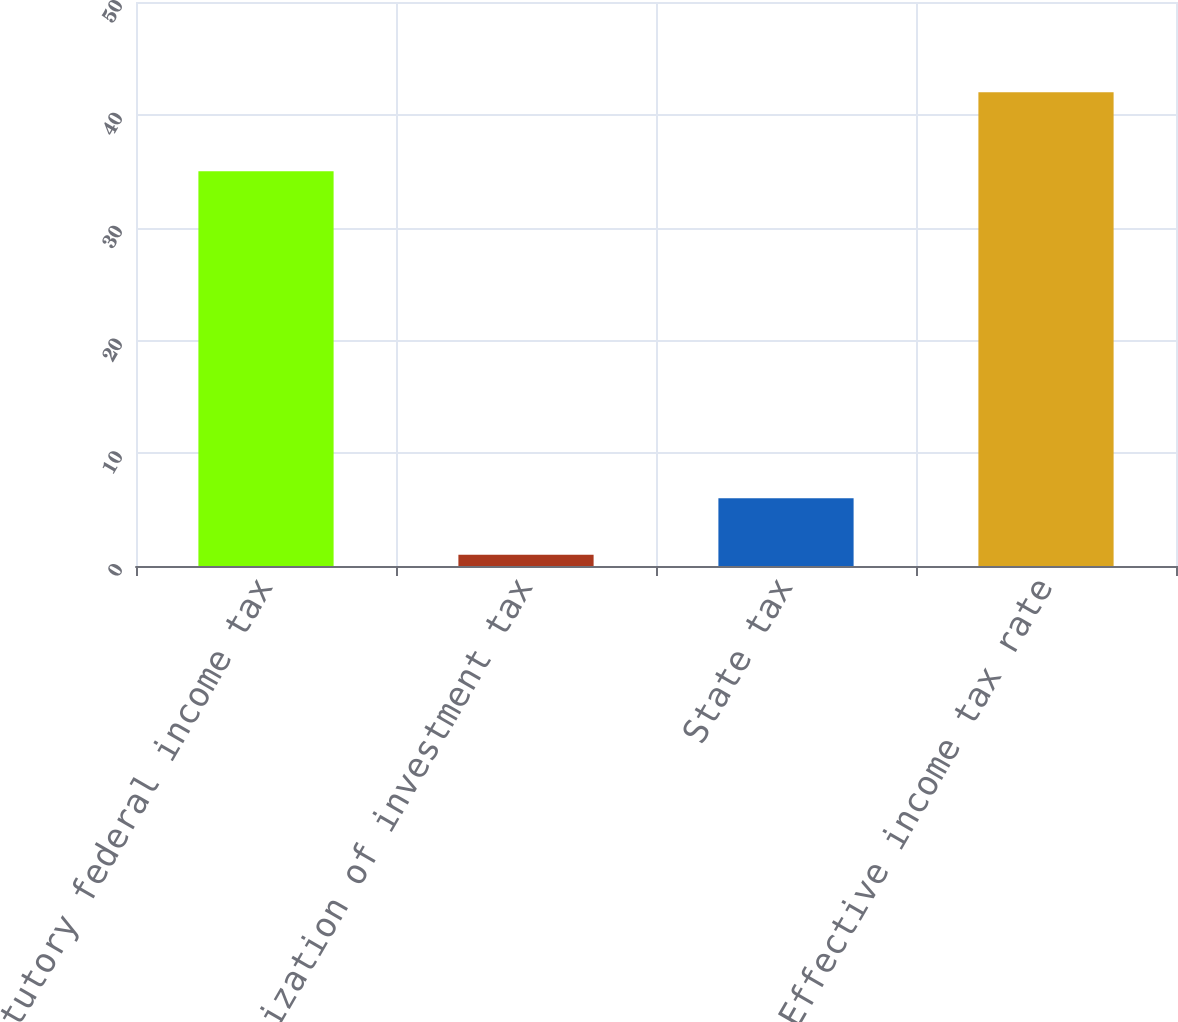<chart> <loc_0><loc_0><loc_500><loc_500><bar_chart><fcel>Statutory federal income tax<fcel>Amortization of investment tax<fcel>State tax<fcel>Effective income tax rate<nl><fcel>35<fcel>1<fcel>6<fcel>42<nl></chart> 